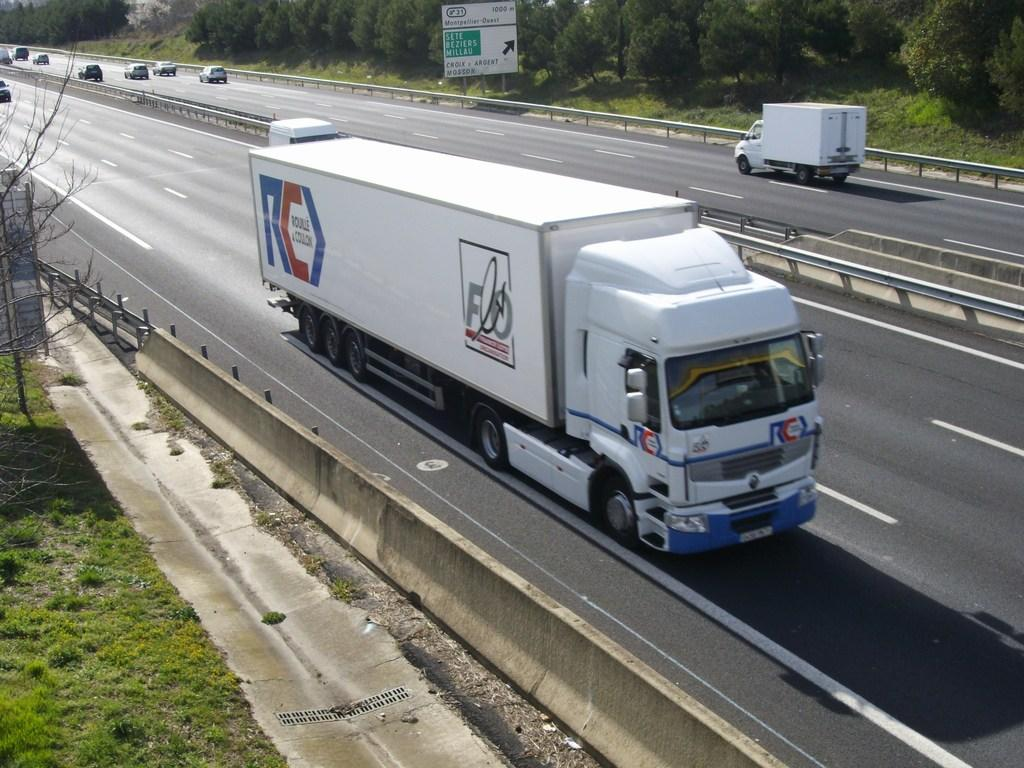What vehicles are present in the center of the image? There are trucks and cars in the center of the image. What is the main feature in the center of the image? There is a road in the center of the image. What type of vegetation is on the left side of the image? There is grass and a tree on the left side of the image. What can be seen at the top of the image? There are trees and boards at the top of the image. What day of the week is depicted in the image? The image does not depict a specific day of the week; it shows vehicles, a road, and vegetation. How many trees are present in the image? There are multiple trees present in the image, including those on the left side and at the top of the image. 